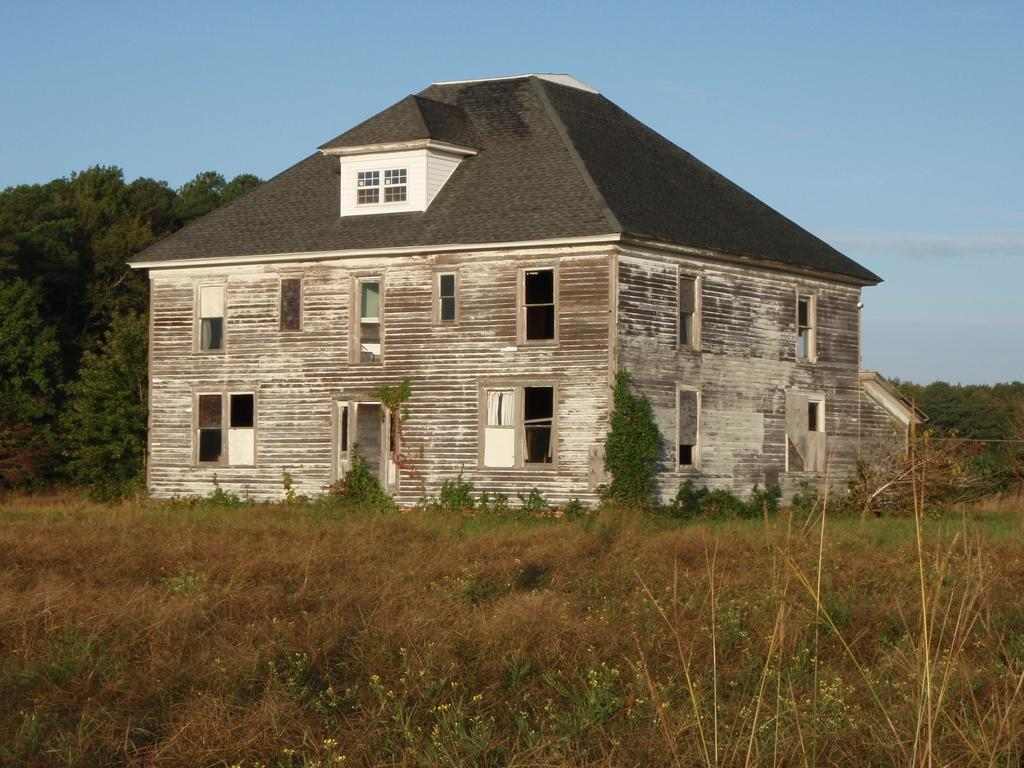What is the main subject of the image? The main subject of the image is a house. What can be seen on the ground in front of the house? There is grass on the surface in front of the house. What type of vegetation is visible at the back side of the image? There are trees at the back side of the image. What is visible above the house and trees? The sky is visible in the image. Can you tell me how many beggars are standing near the house in the image? There are no beggars present in the image. What type of hill can be seen in the background of the image? There is no hill visible in the image; it features a house, grass, trees, and the sky. 